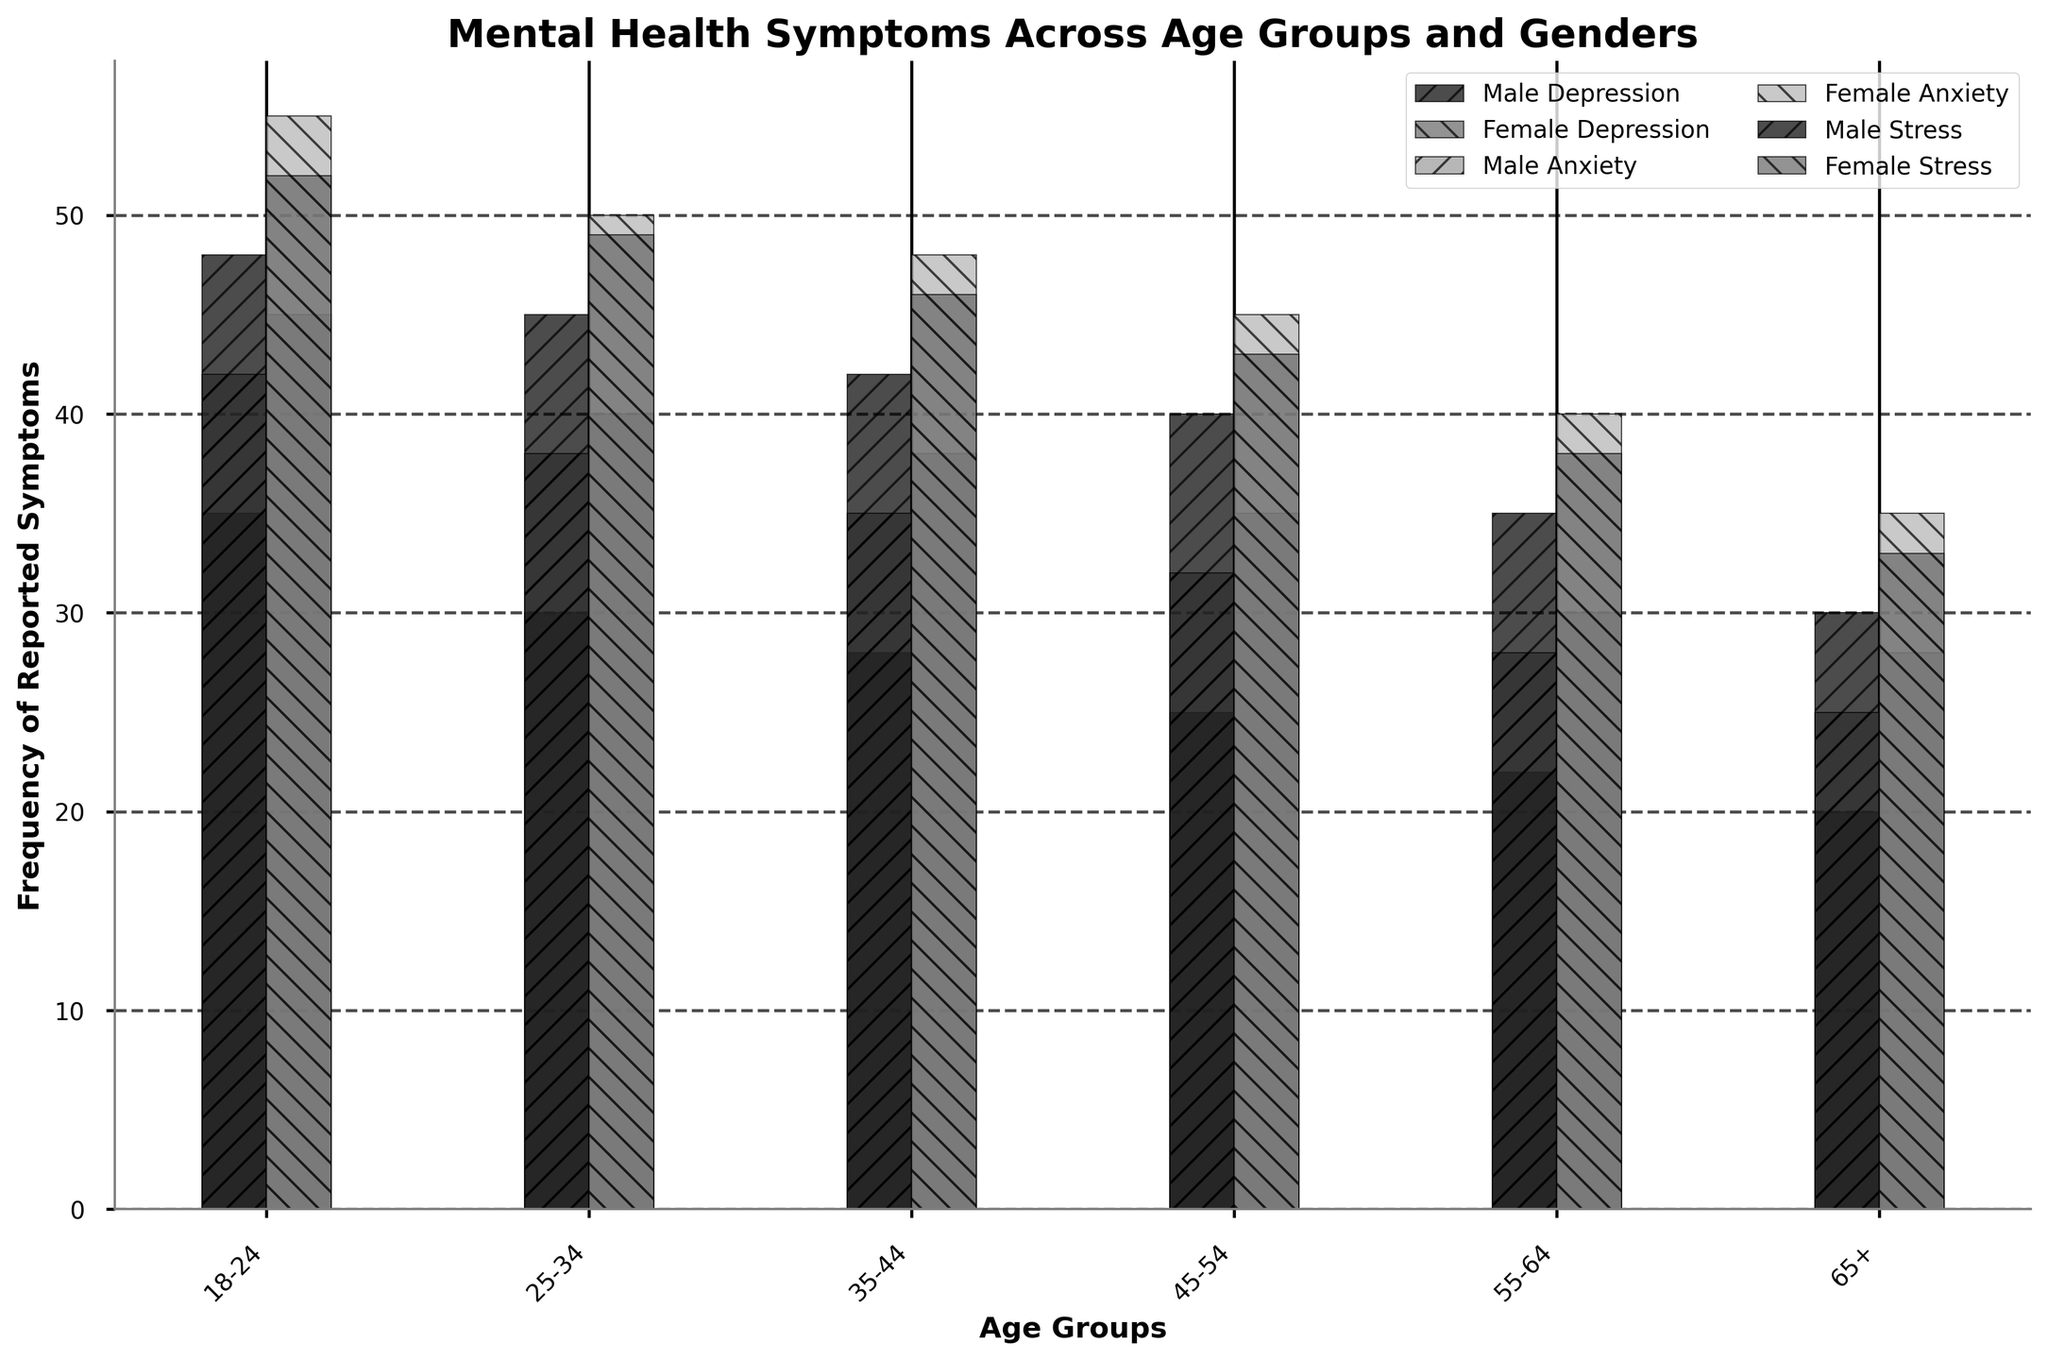What's the difference in the frequency of reported depression symptoms between males and females in the 18-24 age group? Check the height of the bars for depression in the 18-24 age group. The male depression bar is at 35, while the female bar is at 45. The difference is 45 - 35 = 10.
Answer: 10 In which age group do females report the highest level of anxiety symptoms? Look at the bars for anxiety across different age groups for females. The highest anxiety level for females is in the 18-24 age group at 55.
Answer: 18-24 Which gender reports more stress in the 55-64 age group? Compare the height of the stress bars in the 55-64 age group for both genders. The female stress bar is at 38, whereas the male stress bar is at 35. Thus, females report more stress.
Answer: Female How does the frequency of reported anxiety symptoms in 45-54 aged males compare to that in 65+ aged males? Check the anxiety bars for males in 45-54 and 65+ age groups. For 45-54 males, the anxiety level is 32, and for 65+ males, it is 25. Thus, 32 - 25 = 7, and 32 is greater than 25.
Answer: 7, greater What's the total frequency of reported stress symptoms across all age groups for males? Add up the stress values for males across all age groups: 48 (18-24) + 45 (25-34) + 42 (35-44) + 40 (45-54) + 35 (55-64) + 30 (65+). The total is 48 + 45 + 42 + 40 + 35 + 30 = 240.
Answer: 240 Which age group sees the smallest gender difference in reported depression symptoms? Calculate the difference in the reported depression symptoms between males and females for each age group. The differences are: 
18-24: 45 - 35 = 10 
25-34: 40 - 30 = 10 
35-44: 38 - 28 = 10 
45-54: 35 - 25 = 10 
55-64: 30 - 22 = 8 
65+: 28 - 20 = 8 
The smallest differences are in the 55-64 and 65+ age groups, both at 8.
Answer: 55-64 and 65+ What is the average frequency of reported depression symptoms in the 25-34 age group for both genders? Calculate the average by adding the depression values for males and females in the 25-34 age group and divide by 2: (30 + 40) / 2 = 70 / 2 = 35.
Answer: 35 In which age group do males report higher levels of depression than females? Check the bars for depression in each age group and compare males to females. There are no age groups where males report higher levels of depression than females.
Answer: None Does the stress level for females in the 25-34 age group exceed that of any other age group? Compare the stress level for females in the 25-34 age group (49) with the stress levels in other age groups. While it is higher than several other age groups, it does not exceed the 18-24 or 35-44 female stress levels. Thus, it does not exceed all other groups.
Answer: No 